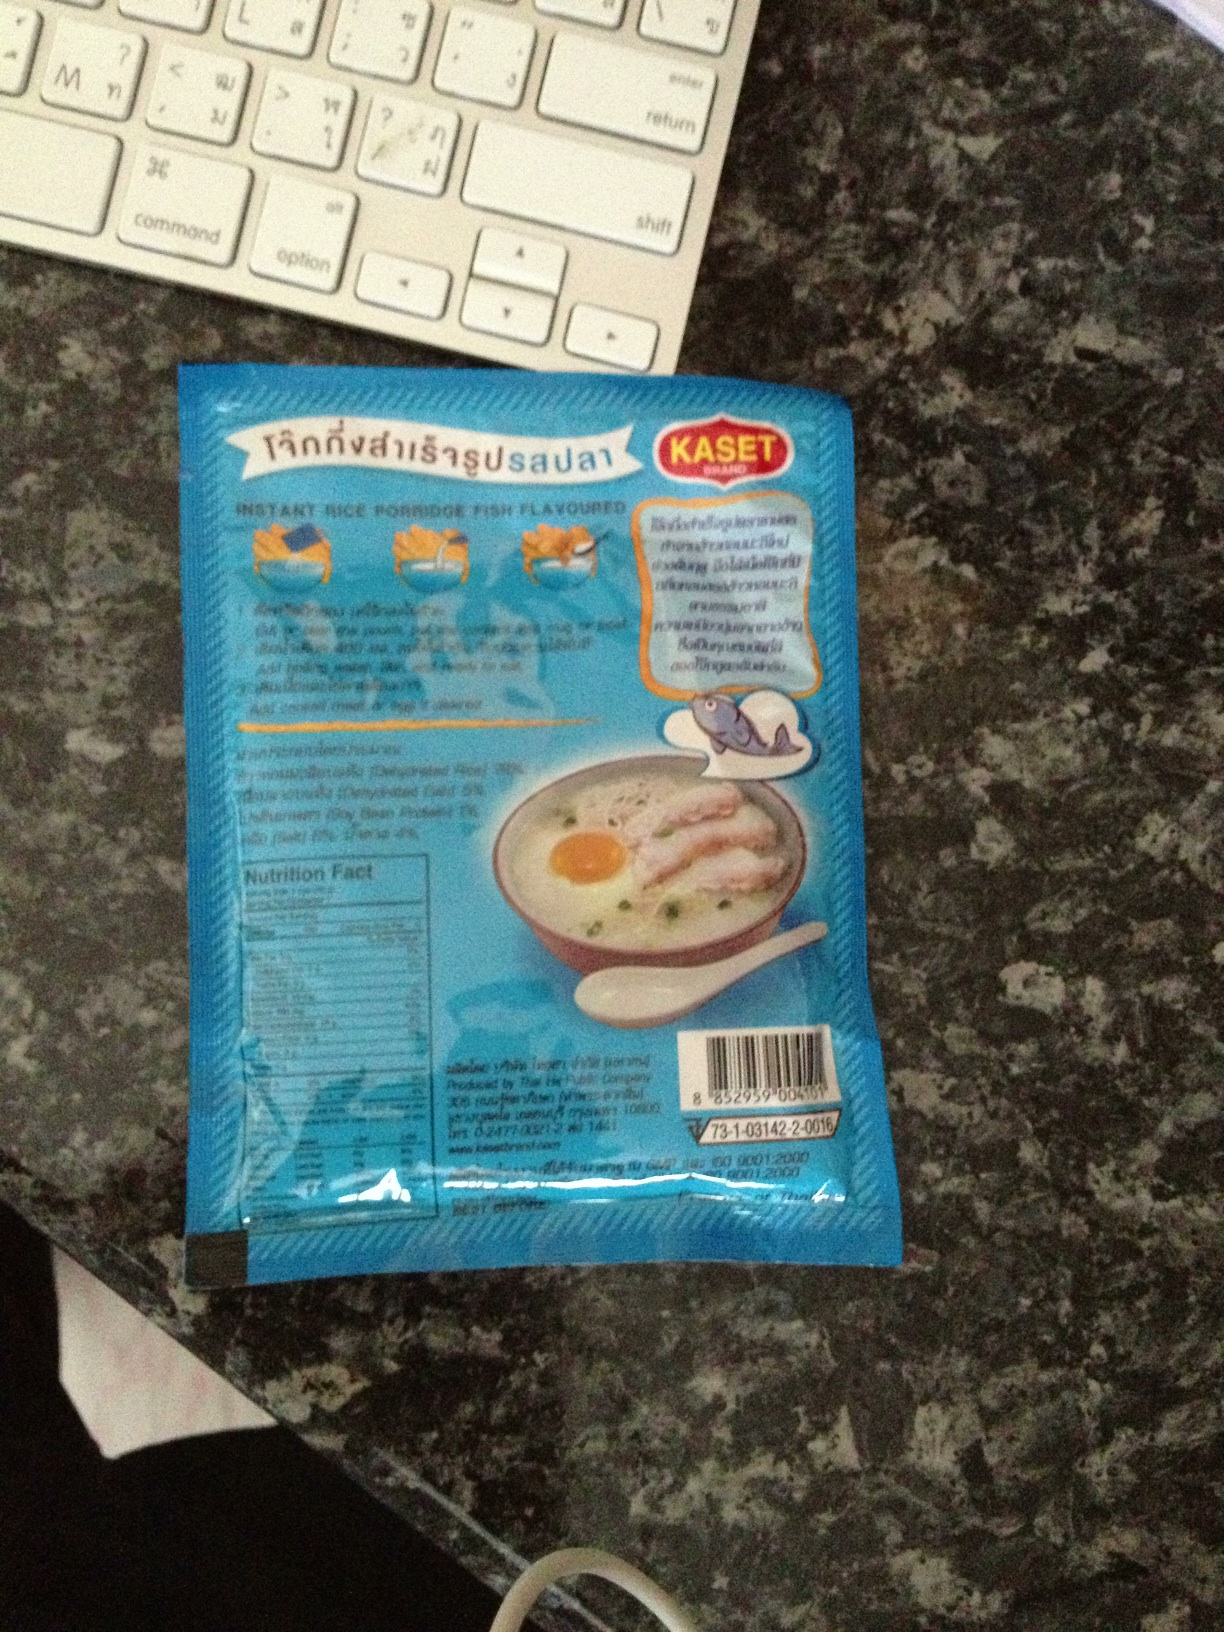Can you tell me about the instructions for preparing this food? The image shows the back of a food package, likely containing preparation instructions, but the text is not clear enough to read in the provided image. Generally, instant rice porridge can be prepared by adding hot water or by cooking it in a microwave. 